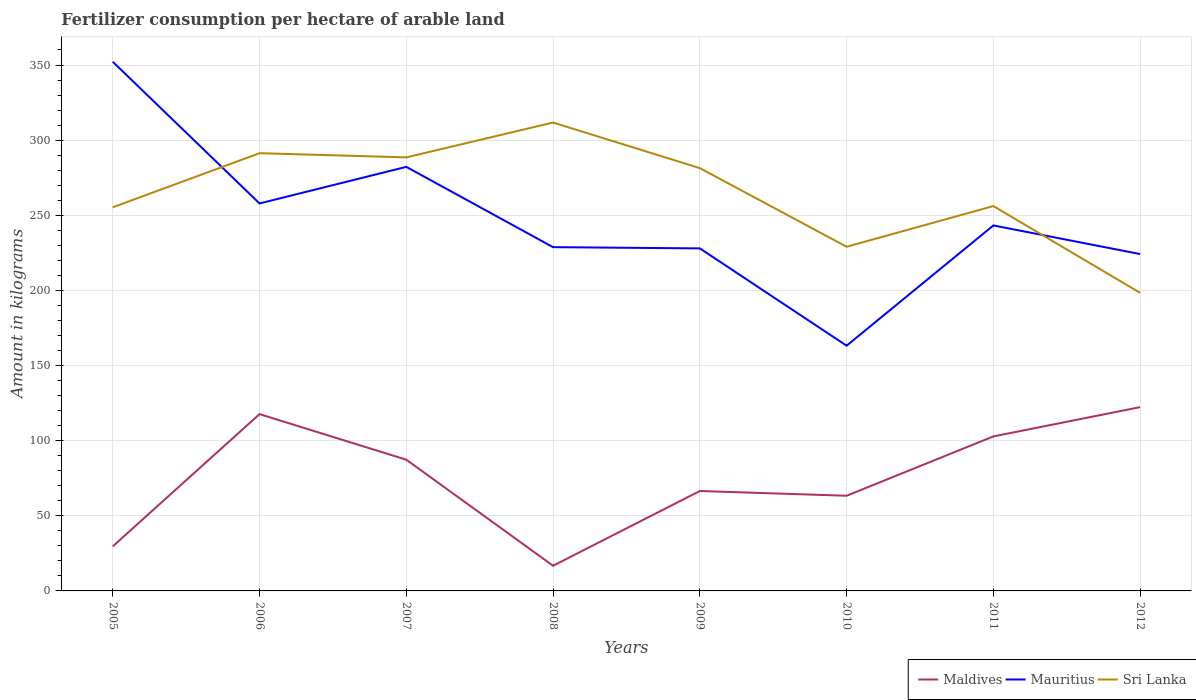How many different coloured lines are there?
Offer a terse response. 3. Is the number of lines equal to the number of legend labels?
Keep it short and to the point. Yes. Across all years, what is the maximum amount of fertilizer consumption in Maldives?
Provide a short and direct response. 16.75. In which year was the amount of fertilizer consumption in Sri Lanka maximum?
Make the answer very short. 2012. What is the total amount of fertilizer consumption in Sri Lanka in the graph?
Give a very brief answer. 92.95. What is the difference between the highest and the second highest amount of fertilizer consumption in Maldives?
Offer a terse response. 105.56. What is the difference between the highest and the lowest amount of fertilizer consumption in Sri Lanka?
Offer a very short reply. 4. What is the difference between two consecutive major ticks on the Y-axis?
Keep it short and to the point. 50. Are the values on the major ticks of Y-axis written in scientific E-notation?
Your response must be concise. No. Does the graph contain grids?
Your response must be concise. Yes. Where does the legend appear in the graph?
Make the answer very short. Bottom right. What is the title of the graph?
Ensure brevity in your answer.  Fertilizer consumption per hectare of arable land. Does "Sierra Leone" appear as one of the legend labels in the graph?
Offer a terse response. No. What is the label or title of the Y-axis?
Make the answer very short. Amount in kilograms. What is the Amount in kilograms in Maldives in 2005?
Offer a very short reply. 29.67. What is the Amount in kilograms in Mauritius in 2005?
Your answer should be very brief. 352.15. What is the Amount in kilograms in Sri Lanka in 2005?
Give a very brief answer. 255.29. What is the Amount in kilograms in Maldives in 2006?
Offer a very short reply. 117.67. What is the Amount in kilograms of Mauritius in 2006?
Make the answer very short. 257.87. What is the Amount in kilograms of Sri Lanka in 2006?
Offer a terse response. 291.32. What is the Amount in kilograms of Maldives in 2007?
Make the answer very short. 87.33. What is the Amount in kilograms in Mauritius in 2007?
Your response must be concise. 282.22. What is the Amount in kilograms in Sri Lanka in 2007?
Give a very brief answer. 288.52. What is the Amount in kilograms of Maldives in 2008?
Offer a terse response. 16.75. What is the Amount in kilograms in Mauritius in 2008?
Provide a short and direct response. 228.78. What is the Amount in kilograms of Sri Lanka in 2008?
Ensure brevity in your answer.  311.71. What is the Amount in kilograms in Maldives in 2009?
Your response must be concise. 66.5. What is the Amount in kilograms in Mauritius in 2009?
Your answer should be compact. 227.96. What is the Amount in kilograms in Sri Lanka in 2009?
Give a very brief answer. 281.38. What is the Amount in kilograms in Maldives in 2010?
Give a very brief answer. 63.33. What is the Amount in kilograms of Mauritius in 2010?
Your answer should be very brief. 163.2. What is the Amount in kilograms of Sri Lanka in 2010?
Offer a terse response. 229.05. What is the Amount in kilograms of Maldives in 2011?
Offer a terse response. 102.82. What is the Amount in kilograms of Mauritius in 2011?
Provide a succinct answer. 243.23. What is the Amount in kilograms of Sri Lanka in 2011?
Offer a very short reply. 256.12. What is the Amount in kilograms in Maldives in 2012?
Provide a short and direct response. 122.31. What is the Amount in kilograms in Mauritius in 2012?
Make the answer very short. 224.18. What is the Amount in kilograms in Sri Lanka in 2012?
Ensure brevity in your answer.  198.37. Across all years, what is the maximum Amount in kilograms of Maldives?
Provide a short and direct response. 122.31. Across all years, what is the maximum Amount in kilograms of Mauritius?
Make the answer very short. 352.15. Across all years, what is the maximum Amount in kilograms in Sri Lanka?
Provide a short and direct response. 311.71. Across all years, what is the minimum Amount in kilograms of Maldives?
Offer a very short reply. 16.75. Across all years, what is the minimum Amount in kilograms in Mauritius?
Give a very brief answer. 163.2. Across all years, what is the minimum Amount in kilograms of Sri Lanka?
Your answer should be compact. 198.37. What is the total Amount in kilograms of Maldives in the graph?
Make the answer very short. 606.38. What is the total Amount in kilograms of Mauritius in the graph?
Offer a very short reply. 1979.6. What is the total Amount in kilograms of Sri Lanka in the graph?
Keep it short and to the point. 2111.76. What is the difference between the Amount in kilograms in Maldives in 2005 and that in 2006?
Offer a very short reply. -88. What is the difference between the Amount in kilograms in Mauritius in 2005 and that in 2006?
Offer a terse response. 94.29. What is the difference between the Amount in kilograms of Sri Lanka in 2005 and that in 2006?
Keep it short and to the point. -36.02. What is the difference between the Amount in kilograms in Maldives in 2005 and that in 2007?
Your answer should be compact. -57.67. What is the difference between the Amount in kilograms in Mauritius in 2005 and that in 2007?
Your answer should be very brief. 69.93. What is the difference between the Amount in kilograms in Sri Lanka in 2005 and that in 2007?
Your response must be concise. -33.23. What is the difference between the Amount in kilograms in Maldives in 2005 and that in 2008?
Offer a terse response. 12.92. What is the difference between the Amount in kilograms in Mauritius in 2005 and that in 2008?
Give a very brief answer. 123.38. What is the difference between the Amount in kilograms of Sri Lanka in 2005 and that in 2008?
Your answer should be very brief. -56.42. What is the difference between the Amount in kilograms in Maldives in 2005 and that in 2009?
Ensure brevity in your answer.  -36.83. What is the difference between the Amount in kilograms in Mauritius in 2005 and that in 2009?
Your answer should be compact. 124.19. What is the difference between the Amount in kilograms in Sri Lanka in 2005 and that in 2009?
Keep it short and to the point. -26.08. What is the difference between the Amount in kilograms of Maldives in 2005 and that in 2010?
Your response must be concise. -33.67. What is the difference between the Amount in kilograms in Mauritius in 2005 and that in 2010?
Offer a terse response. 188.95. What is the difference between the Amount in kilograms in Sri Lanka in 2005 and that in 2010?
Provide a succinct answer. 26.24. What is the difference between the Amount in kilograms of Maldives in 2005 and that in 2011?
Your answer should be very brief. -73.15. What is the difference between the Amount in kilograms of Mauritius in 2005 and that in 2011?
Provide a short and direct response. 108.92. What is the difference between the Amount in kilograms of Sri Lanka in 2005 and that in 2011?
Give a very brief answer. -0.83. What is the difference between the Amount in kilograms of Maldives in 2005 and that in 2012?
Provide a succinct answer. -92.64. What is the difference between the Amount in kilograms of Mauritius in 2005 and that in 2012?
Your response must be concise. 127.97. What is the difference between the Amount in kilograms in Sri Lanka in 2005 and that in 2012?
Offer a terse response. 56.92. What is the difference between the Amount in kilograms of Maldives in 2006 and that in 2007?
Offer a terse response. 30.33. What is the difference between the Amount in kilograms of Mauritius in 2006 and that in 2007?
Keep it short and to the point. -24.35. What is the difference between the Amount in kilograms in Sri Lanka in 2006 and that in 2007?
Your response must be concise. 2.79. What is the difference between the Amount in kilograms of Maldives in 2006 and that in 2008?
Provide a succinct answer. 100.92. What is the difference between the Amount in kilograms in Mauritius in 2006 and that in 2008?
Provide a short and direct response. 29.09. What is the difference between the Amount in kilograms in Sri Lanka in 2006 and that in 2008?
Make the answer very short. -20.4. What is the difference between the Amount in kilograms in Maldives in 2006 and that in 2009?
Keep it short and to the point. 51.17. What is the difference between the Amount in kilograms in Mauritius in 2006 and that in 2009?
Ensure brevity in your answer.  29.91. What is the difference between the Amount in kilograms of Sri Lanka in 2006 and that in 2009?
Give a very brief answer. 9.94. What is the difference between the Amount in kilograms in Maldives in 2006 and that in 2010?
Ensure brevity in your answer.  54.33. What is the difference between the Amount in kilograms in Mauritius in 2006 and that in 2010?
Give a very brief answer. 94.67. What is the difference between the Amount in kilograms of Sri Lanka in 2006 and that in 2010?
Your response must be concise. 62.27. What is the difference between the Amount in kilograms in Maldives in 2006 and that in 2011?
Provide a short and direct response. 14.85. What is the difference between the Amount in kilograms of Mauritius in 2006 and that in 2011?
Your response must be concise. 14.64. What is the difference between the Amount in kilograms of Sri Lanka in 2006 and that in 2011?
Provide a short and direct response. 35.19. What is the difference between the Amount in kilograms of Maldives in 2006 and that in 2012?
Give a very brief answer. -4.64. What is the difference between the Amount in kilograms of Mauritius in 2006 and that in 2012?
Keep it short and to the point. 33.68. What is the difference between the Amount in kilograms in Sri Lanka in 2006 and that in 2012?
Offer a terse response. 92.95. What is the difference between the Amount in kilograms in Maldives in 2007 and that in 2008?
Your answer should be compact. 70.58. What is the difference between the Amount in kilograms in Mauritius in 2007 and that in 2008?
Offer a very short reply. 53.45. What is the difference between the Amount in kilograms of Sri Lanka in 2007 and that in 2008?
Offer a terse response. -23.19. What is the difference between the Amount in kilograms of Maldives in 2007 and that in 2009?
Make the answer very short. 20.83. What is the difference between the Amount in kilograms in Mauritius in 2007 and that in 2009?
Provide a succinct answer. 54.26. What is the difference between the Amount in kilograms of Sri Lanka in 2007 and that in 2009?
Keep it short and to the point. 7.15. What is the difference between the Amount in kilograms of Maldives in 2007 and that in 2010?
Provide a short and direct response. 24. What is the difference between the Amount in kilograms of Mauritius in 2007 and that in 2010?
Keep it short and to the point. 119.02. What is the difference between the Amount in kilograms of Sri Lanka in 2007 and that in 2010?
Offer a terse response. 59.48. What is the difference between the Amount in kilograms in Maldives in 2007 and that in 2011?
Your answer should be compact. -15.49. What is the difference between the Amount in kilograms in Mauritius in 2007 and that in 2011?
Keep it short and to the point. 38.99. What is the difference between the Amount in kilograms in Sri Lanka in 2007 and that in 2011?
Offer a very short reply. 32.4. What is the difference between the Amount in kilograms in Maldives in 2007 and that in 2012?
Your answer should be very brief. -34.97. What is the difference between the Amount in kilograms in Mauritius in 2007 and that in 2012?
Offer a very short reply. 58.04. What is the difference between the Amount in kilograms in Sri Lanka in 2007 and that in 2012?
Provide a short and direct response. 90.16. What is the difference between the Amount in kilograms of Maldives in 2008 and that in 2009?
Provide a succinct answer. -49.75. What is the difference between the Amount in kilograms in Mauritius in 2008 and that in 2009?
Ensure brevity in your answer.  0.81. What is the difference between the Amount in kilograms of Sri Lanka in 2008 and that in 2009?
Ensure brevity in your answer.  30.34. What is the difference between the Amount in kilograms of Maldives in 2008 and that in 2010?
Offer a terse response. -46.58. What is the difference between the Amount in kilograms in Mauritius in 2008 and that in 2010?
Keep it short and to the point. 65.58. What is the difference between the Amount in kilograms in Sri Lanka in 2008 and that in 2010?
Provide a short and direct response. 82.66. What is the difference between the Amount in kilograms in Maldives in 2008 and that in 2011?
Keep it short and to the point. -86.07. What is the difference between the Amount in kilograms of Mauritius in 2008 and that in 2011?
Provide a short and direct response. -14.46. What is the difference between the Amount in kilograms in Sri Lanka in 2008 and that in 2011?
Make the answer very short. 55.59. What is the difference between the Amount in kilograms of Maldives in 2008 and that in 2012?
Your answer should be very brief. -105.56. What is the difference between the Amount in kilograms of Mauritius in 2008 and that in 2012?
Your answer should be very brief. 4.59. What is the difference between the Amount in kilograms in Sri Lanka in 2008 and that in 2012?
Offer a terse response. 113.34. What is the difference between the Amount in kilograms in Maldives in 2009 and that in 2010?
Keep it short and to the point. 3.17. What is the difference between the Amount in kilograms in Mauritius in 2009 and that in 2010?
Give a very brief answer. 64.76. What is the difference between the Amount in kilograms in Sri Lanka in 2009 and that in 2010?
Your response must be concise. 52.33. What is the difference between the Amount in kilograms of Maldives in 2009 and that in 2011?
Make the answer very short. -36.32. What is the difference between the Amount in kilograms in Mauritius in 2009 and that in 2011?
Your response must be concise. -15.27. What is the difference between the Amount in kilograms in Sri Lanka in 2009 and that in 2011?
Your answer should be compact. 25.25. What is the difference between the Amount in kilograms of Maldives in 2009 and that in 2012?
Offer a very short reply. -55.81. What is the difference between the Amount in kilograms in Mauritius in 2009 and that in 2012?
Your answer should be very brief. 3.78. What is the difference between the Amount in kilograms in Sri Lanka in 2009 and that in 2012?
Ensure brevity in your answer.  83.01. What is the difference between the Amount in kilograms in Maldives in 2010 and that in 2011?
Ensure brevity in your answer.  -39.49. What is the difference between the Amount in kilograms in Mauritius in 2010 and that in 2011?
Provide a short and direct response. -80.03. What is the difference between the Amount in kilograms in Sri Lanka in 2010 and that in 2011?
Make the answer very short. -27.08. What is the difference between the Amount in kilograms of Maldives in 2010 and that in 2012?
Offer a very short reply. -58.97. What is the difference between the Amount in kilograms of Mauritius in 2010 and that in 2012?
Ensure brevity in your answer.  -60.98. What is the difference between the Amount in kilograms in Sri Lanka in 2010 and that in 2012?
Keep it short and to the point. 30.68. What is the difference between the Amount in kilograms of Maldives in 2011 and that in 2012?
Your answer should be very brief. -19.49. What is the difference between the Amount in kilograms in Mauritius in 2011 and that in 2012?
Keep it short and to the point. 19.05. What is the difference between the Amount in kilograms of Sri Lanka in 2011 and that in 2012?
Your answer should be very brief. 57.75. What is the difference between the Amount in kilograms of Maldives in 2005 and the Amount in kilograms of Mauritius in 2006?
Make the answer very short. -228.2. What is the difference between the Amount in kilograms of Maldives in 2005 and the Amount in kilograms of Sri Lanka in 2006?
Ensure brevity in your answer.  -261.65. What is the difference between the Amount in kilograms of Mauritius in 2005 and the Amount in kilograms of Sri Lanka in 2006?
Your answer should be very brief. 60.84. What is the difference between the Amount in kilograms in Maldives in 2005 and the Amount in kilograms in Mauritius in 2007?
Offer a very short reply. -252.56. What is the difference between the Amount in kilograms of Maldives in 2005 and the Amount in kilograms of Sri Lanka in 2007?
Make the answer very short. -258.86. What is the difference between the Amount in kilograms of Mauritius in 2005 and the Amount in kilograms of Sri Lanka in 2007?
Provide a short and direct response. 63.63. What is the difference between the Amount in kilograms in Maldives in 2005 and the Amount in kilograms in Mauritius in 2008?
Provide a succinct answer. -199.11. What is the difference between the Amount in kilograms of Maldives in 2005 and the Amount in kilograms of Sri Lanka in 2008?
Ensure brevity in your answer.  -282.05. What is the difference between the Amount in kilograms of Mauritius in 2005 and the Amount in kilograms of Sri Lanka in 2008?
Offer a very short reply. 40.44. What is the difference between the Amount in kilograms in Maldives in 2005 and the Amount in kilograms in Mauritius in 2009?
Keep it short and to the point. -198.3. What is the difference between the Amount in kilograms in Maldives in 2005 and the Amount in kilograms in Sri Lanka in 2009?
Your response must be concise. -251.71. What is the difference between the Amount in kilograms of Mauritius in 2005 and the Amount in kilograms of Sri Lanka in 2009?
Offer a very short reply. 70.78. What is the difference between the Amount in kilograms in Maldives in 2005 and the Amount in kilograms in Mauritius in 2010?
Provide a succinct answer. -133.53. What is the difference between the Amount in kilograms in Maldives in 2005 and the Amount in kilograms in Sri Lanka in 2010?
Keep it short and to the point. -199.38. What is the difference between the Amount in kilograms in Mauritius in 2005 and the Amount in kilograms in Sri Lanka in 2010?
Your response must be concise. 123.11. What is the difference between the Amount in kilograms in Maldives in 2005 and the Amount in kilograms in Mauritius in 2011?
Ensure brevity in your answer.  -213.56. What is the difference between the Amount in kilograms of Maldives in 2005 and the Amount in kilograms of Sri Lanka in 2011?
Provide a succinct answer. -226.46. What is the difference between the Amount in kilograms of Mauritius in 2005 and the Amount in kilograms of Sri Lanka in 2011?
Your answer should be very brief. 96.03. What is the difference between the Amount in kilograms of Maldives in 2005 and the Amount in kilograms of Mauritius in 2012?
Keep it short and to the point. -194.52. What is the difference between the Amount in kilograms in Maldives in 2005 and the Amount in kilograms in Sri Lanka in 2012?
Make the answer very short. -168.7. What is the difference between the Amount in kilograms of Mauritius in 2005 and the Amount in kilograms of Sri Lanka in 2012?
Make the answer very short. 153.78. What is the difference between the Amount in kilograms of Maldives in 2006 and the Amount in kilograms of Mauritius in 2007?
Offer a terse response. -164.56. What is the difference between the Amount in kilograms of Maldives in 2006 and the Amount in kilograms of Sri Lanka in 2007?
Give a very brief answer. -170.86. What is the difference between the Amount in kilograms of Mauritius in 2006 and the Amount in kilograms of Sri Lanka in 2007?
Offer a very short reply. -30.66. What is the difference between the Amount in kilograms of Maldives in 2006 and the Amount in kilograms of Mauritius in 2008?
Offer a terse response. -111.11. What is the difference between the Amount in kilograms in Maldives in 2006 and the Amount in kilograms in Sri Lanka in 2008?
Your answer should be compact. -194.04. What is the difference between the Amount in kilograms of Mauritius in 2006 and the Amount in kilograms of Sri Lanka in 2008?
Your answer should be compact. -53.84. What is the difference between the Amount in kilograms of Maldives in 2006 and the Amount in kilograms of Mauritius in 2009?
Offer a very short reply. -110.3. What is the difference between the Amount in kilograms in Maldives in 2006 and the Amount in kilograms in Sri Lanka in 2009?
Make the answer very short. -163.71. What is the difference between the Amount in kilograms in Mauritius in 2006 and the Amount in kilograms in Sri Lanka in 2009?
Offer a terse response. -23.51. What is the difference between the Amount in kilograms of Maldives in 2006 and the Amount in kilograms of Mauritius in 2010?
Keep it short and to the point. -45.53. What is the difference between the Amount in kilograms of Maldives in 2006 and the Amount in kilograms of Sri Lanka in 2010?
Your answer should be very brief. -111.38. What is the difference between the Amount in kilograms in Mauritius in 2006 and the Amount in kilograms in Sri Lanka in 2010?
Your answer should be compact. 28.82. What is the difference between the Amount in kilograms of Maldives in 2006 and the Amount in kilograms of Mauritius in 2011?
Provide a short and direct response. -125.56. What is the difference between the Amount in kilograms in Maldives in 2006 and the Amount in kilograms in Sri Lanka in 2011?
Your answer should be compact. -138.46. What is the difference between the Amount in kilograms in Mauritius in 2006 and the Amount in kilograms in Sri Lanka in 2011?
Your answer should be compact. 1.74. What is the difference between the Amount in kilograms of Maldives in 2006 and the Amount in kilograms of Mauritius in 2012?
Provide a short and direct response. -106.52. What is the difference between the Amount in kilograms of Maldives in 2006 and the Amount in kilograms of Sri Lanka in 2012?
Provide a succinct answer. -80.7. What is the difference between the Amount in kilograms of Mauritius in 2006 and the Amount in kilograms of Sri Lanka in 2012?
Ensure brevity in your answer.  59.5. What is the difference between the Amount in kilograms of Maldives in 2007 and the Amount in kilograms of Mauritius in 2008?
Your response must be concise. -141.44. What is the difference between the Amount in kilograms in Maldives in 2007 and the Amount in kilograms in Sri Lanka in 2008?
Give a very brief answer. -224.38. What is the difference between the Amount in kilograms in Mauritius in 2007 and the Amount in kilograms in Sri Lanka in 2008?
Give a very brief answer. -29.49. What is the difference between the Amount in kilograms in Maldives in 2007 and the Amount in kilograms in Mauritius in 2009?
Your answer should be compact. -140.63. What is the difference between the Amount in kilograms in Maldives in 2007 and the Amount in kilograms in Sri Lanka in 2009?
Provide a short and direct response. -194.04. What is the difference between the Amount in kilograms in Mauritius in 2007 and the Amount in kilograms in Sri Lanka in 2009?
Ensure brevity in your answer.  0.85. What is the difference between the Amount in kilograms in Maldives in 2007 and the Amount in kilograms in Mauritius in 2010?
Offer a very short reply. -75.87. What is the difference between the Amount in kilograms in Maldives in 2007 and the Amount in kilograms in Sri Lanka in 2010?
Give a very brief answer. -141.71. What is the difference between the Amount in kilograms in Mauritius in 2007 and the Amount in kilograms in Sri Lanka in 2010?
Your response must be concise. 53.17. What is the difference between the Amount in kilograms in Maldives in 2007 and the Amount in kilograms in Mauritius in 2011?
Your answer should be very brief. -155.9. What is the difference between the Amount in kilograms in Maldives in 2007 and the Amount in kilograms in Sri Lanka in 2011?
Your answer should be compact. -168.79. What is the difference between the Amount in kilograms in Mauritius in 2007 and the Amount in kilograms in Sri Lanka in 2011?
Offer a very short reply. 26.1. What is the difference between the Amount in kilograms of Maldives in 2007 and the Amount in kilograms of Mauritius in 2012?
Offer a very short reply. -136.85. What is the difference between the Amount in kilograms in Maldives in 2007 and the Amount in kilograms in Sri Lanka in 2012?
Give a very brief answer. -111.04. What is the difference between the Amount in kilograms of Mauritius in 2007 and the Amount in kilograms of Sri Lanka in 2012?
Your answer should be very brief. 83.85. What is the difference between the Amount in kilograms in Maldives in 2008 and the Amount in kilograms in Mauritius in 2009?
Ensure brevity in your answer.  -211.21. What is the difference between the Amount in kilograms of Maldives in 2008 and the Amount in kilograms of Sri Lanka in 2009?
Offer a terse response. -264.63. What is the difference between the Amount in kilograms of Mauritius in 2008 and the Amount in kilograms of Sri Lanka in 2009?
Make the answer very short. -52.6. What is the difference between the Amount in kilograms in Maldives in 2008 and the Amount in kilograms in Mauritius in 2010?
Ensure brevity in your answer.  -146.45. What is the difference between the Amount in kilograms in Maldives in 2008 and the Amount in kilograms in Sri Lanka in 2010?
Provide a succinct answer. -212.3. What is the difference between the Amount in kilograms of Mauritius in 2008 and the Amount in kilograms of Sri Lanka in 2010?
Make the answer very short. -0.27. What is the difference between the Amount in kilograms of Maldives in 2008 and the Amount in kilograms of Mauritius in 2011?
Offer a very short reply. -226.48. What is the difference between the Amount in kilograms in Maldives in 2008 and the Amount in kilograms in Sri Lanka in 2011?
Offer a terse response. -239.37. What is the difference between the Amount in kilograms in Mauritius in 2008 and the Amount in kilograms in Sri Lanka in 2011?
Your answer should be very brief. -27.35. What is the difference between the Amount in kilograms in Maldives in 2008 and the Amount in kilograms in Mauritius in 2012?
Your answer should be compact. -207.43. What is the difference between the Amount in kilograms in Maldives in 2008 and the Amount in kilograms in Sri Lanka in 2012?
Ensure brevity in your answer.  -181.62. What is the difference between the Amount in kilograms in Mauritius in 2008 and the Amount in kilograms in Sri Lanka in 2012?
Your answer should be very brief. 30.41. What is the difference between the Amount in kilograms in Maldives in 2009 and the Amount in kilograms in Mauritius in 2010?
Give a very brief answer. -96.7. What is the difference between the Amount in kilograms of Maldives in 2009 and the Amount in kilograms of Sri Lanka in 2010?
Your answer should be compact. -162.55. What is the difference between the Amount in kilograms in Mauritius in 2009 and the Amount in kilograms in Sri Lanka in 2010?
Your response must be concise. -1.08. What is the difference between the Amount in kilograms in Maldives in 2009 and the Amount in kilograms in Mauritius in 2011?
Offer a terse response. -176.73. What is the difference between the Amount in kilograms in Maldives in 2009 and the Amount in kilograms in Sri Lanka in 2011?
Provide a succinct answer. -189.62. What is the difference between the Amount in kilograms of Mauritius in 2009 and the Amount in kilograms of Sri Lanka in 2011?
Provide a succinct answer. -28.16. What is the difference between the Amount in kilograms of Maldives in 2009 and the Amount in kilograms of Mauritius in 2012?
Give a very brief answer. -157.68. What is the difference between the Amount in kilograms of Maldives in 2009 and the Amount in kilograms of Sri Lanka in 2012?
Offer a terse response. -131.87. What is the difference between the Amount in kilograms in Mauritius in 2009 and the Amount in kilograms in Sri Lanka in 2012?
Ensure brevity in your answer.  29.59. What is the difference between the Amount in kilograms of Maldives in 2010 and the Amount in kilograms of Mauritius in 2011?
Offer a very short reply. -179.9. What is the difference between the Amount in kilograms in Maldives in 2010 and the Amount in kilograms in Sri Lanka in 2011?
Provide a succinct answer. -192.79. What is the difference between the Amount in kilograms in Mauritius in 2010 and the Amount in kilograms in Sri Lanka in 2011?
Give a very brief answer. -92.92. What is the difference between the Amount in kilograms in Maldives in 2010 and the Amount in kilograms in Mauritius in 2012?
Ensure brevity in your answer.  -160.85. What is the difference between the Amount in kilograms of Maldives in 2010 and the Amount in kilograms of Sri Lanka in 2012?
Make the answer very short. -135.04. What is the difference between the Amount in kilograms of Mauritius in 2010 and the Amount in kilograms of Sri Lanka in 2012?
Offer a very short reply. -35.17. What is the difference between the Amount in kilograms in Maldives in 2011 and the Amount in kilograms in Mauritius in 2012?
Ensure brevity in your answer.  -121.36. What is the difference between the Amount in kilograms in Maldives in 2011 and the Amount in kilograms in Sri Lanka in 2012?
Keep it short and to the point. -95.55. What is the difference between the Amount in kilograms in Mauritius in 2011 and the Amount in kilograms in Sri Lanka in 2012?
Your answer should be compact. 44.86. What is the average Amount in kilograms of Maldives per year?
Provide a succinct answer. 75.8. What is the average Amount in kilograms in Mauritius per year?
Your answer should be compact. 247.45. What is the average Amount in kilograms of Sri Lanka per year?
Your response must be concise. 263.97. In the year 2005, what is the difference between the Amount in kilograms of Maldives and Amount in kilograms of Mauritius?
Your response must be concise. -322.49. In the year 2005, what is the difference between the Amount in kilograms of Maldives and Amount in kilograms of Sri Lanka?
Keep it short and to the point. -225.63. In the year 2005, what is the difference between the Amount in kilograms in Mauritius and Amount in kilograms in Sri Lanka?
Provide a short and direct response. 96.86. In the year 2006, what is the difference between the Amount in kilograms in Maldives and Amount in kilograms in Mauritius?
Offer a very short reply. -140.2. In the year 2006, what is the difference between the Amount in kilograms in Maldives and Amount in kilograms in Sri Lanka?
Give a very brief answer. -173.65. In the year 2006, what is the difference between the Amount in kilograms of Mauritius and Amount in kilograms of Sri Lanka?
Provide a short and direct response. -33.45. In the year 2007, what is the difference between the Amount in kilograms of Maldives and Amount in kilograms of Mauritius?
Your answer should be very brief. -194.89. In the year 2007, what is the difference between the Amount in kilograms of Maldives and Amount in kilograms of Sri Lanka?
Ensure brevity in your answer.  -201.19. In the year 2007, what is the difference between the Amount in kilograms of Mauritius and Amount in kilograms of Sri Lanka?
Provide a short and direct response. -6.3. In the year 2008, what is the difference between the Amount in kilograms of Maldives and Amount in kilograms of Mauritius?
Offer a terse response. -212.03. In the year 2008, what is the difference between the Amount in kilograms in Maldives and Amount in kilograms in Sri Lanka?
Make the answer very short. -294.96. In the year 2008, what is the difference between the Amount in kilograms of Mauritius and Amount in kilograms of Sri Lanka?
Make the answer very short. -82.94. In the year 2009, what is the difference between the Amount in kilograms in Maldives and Amount in kilograms in Mauritius?
Offer a terse response. -161.46. In the year 2009, what is the difference between the Amount in kilograms in Maldives and Amount in kilograms in Sri Lanka?
Your answer should be compact. -214.88. In the year 2009, what is the difference between the Amount in kilograms in Mauritius and Amount in kilograms in Sri Lanka?
Ensure brevity in your answer.  -53.41. In the year 2010, what is the difference between the Amount in kilograms of Maldives and Amount in kilograms of Mauritius?
Provide a short and direct response. -99.87. In the year 2010, what is the difference between the Amount in kilograms in Maldives and Amount in kilograms in Sri Lanka?
Ensure brevity in your answer.  -165.71. In the year 2010, what is the difference between the Amount in kilograms of Mauritius and Amount in kilograms of Sri Lanka?
Make the answer very short. -65.85. In the year 2011, what is the difference between the Amount in kilograms of Maldives and Amount in kilograms of Mauritius?
Your answer should be compact. -140.41. In the year 2011, what is the difference between the Amount in kilograms in Maldives and Amount in kilograms in Sri Lanka?
Your answer should be compact. -153.3. In the year 2011, what is the difference between the Amount in kilograms of Mauritius and Amount in kilograms of Sri Lanka?
Provide a short and direct response. -12.89. In the year 2012, what is the difference between the Amount in kilograms in Maldives and Amount in kilograms in Mauritius?
Make the answer very short. -101.88. In the year 2012, what is the difference between the Amount in kilograms of Maldives and Amount in kilograms of Sri Lanka?
Make the answer very short. -76.06. In the year 2012, what is the difference between the Amount in kilograms of Mauritius and Amount in kilograms of Sri Lanka?
Ensure brevity in your answer.  25.81. What is the ratio of the Amount in kilograms in Maldives in 2005 to that in 2006?
Keep it short and to the point. 0.25. What is the ratio of the Amount in kilograms of Mauritius in 2005 to that in 2006?
Offer a terse response. 1.37. What is the ratio of the Amount in kilograms of Sri Lanka in 2005 to that in 2006?
Ensure brevity in your answer.  0.88. What is the ratio of the Amount in kilograms in Maldives in 2005 to that in 2007?
Keep it short and to the point. 0.34. What is the ratio of the Amount in kilograms in Mauritius in 2005 to that in 2007?
Give a very brief answer. 1.25. What is the ratio of the Amount in kilograms in Sri Lanka in 2005 to that in 2007?
Provide a short and direct response. 0.88. What is the ratio of the Amount in kilograms of Maldives in 2005 to that in 2008?
Offer a very short reply. 1.77. What is the ratio of the Amount in kilograms in Mauritius in 2005 to that in 2008?
Your response must be concise. 1.54. What is the ratio of the Amount in kilograms in Sri Lanka in 2005 to that in 2008?
Make the answer very short. 0.82. What is the ratio of the Amount in kilograms in Maldives in 2005 to that in 2009?
Ensure brevity in your answer.  0.45. What is the ratio of the Amount in kilograms of Mauritius in 2005 to that in 2009?
Ensure brevity in your answer.  1.54. What is the ratio of the Amount in kilograms of Sri Lanka in 2005 to that in 2009?
Offer a terse response. 0.91. What is the ratio of the Amount in kilograms of Maldives in 2005 to that in 2010?
Provide a short and direct response. 0.47. What is the ratio of the Amount in kilograms in Mauritius in 2005 to that in 2010?
Provide a succinct answer. 2.16. What is the ratio of the Amount in kilograms of Sri Lanka in 2005 to that in 2010?
Your response must be concise. 1.11. What is the ratio of the Amount in kilograms in Maldives in 2005 to that in 2011?
Ensure brevity in your answer.  0.29. What is the ratio of the Amount in kilograms of Mauritius in 2005 to that in 2011?
Your response must be concise. 1.45. What is the ratio of the Amount in kilograms of Maldives in 2005 to that in 2012?
Offer a very short reply. 0.24. What is the ratio of the Amount in kilograms in Mauritius in 2005 to that in 2012?
Keep it short and to the point. 1.57. What is the ratio of the Amount in kilograms in Sri Lanka in 2005 to that in 2012?
Your answer should be compact. 1.29. What is the ratio of the Amount in kilograms in Maldives in 2006 to that in 2007?
Your answer should be compact. 1.35. What is the ratio of the Amount in kilograms in Mauritius in 2006 to that in 2007?
Your answer should be compact. 0.91. What is the ratio of the Amount in kilograms of Sri Lanka in 2006 to that in 2007?
Your response must be concise. 1.01. What is the ratio of the Amount in kilograms in Maldives in 2006 to that in 2008?
Make the answer very short. 7.02. What is the ratio of the Amount in kilograms of Mauritius in 2006 to that in 2008?
Your response must be concise. 1.13. What is the ratio of the Amount in kilograms of Sri Lanka in 2006 to that in 2008?
Ensure brevity in your answer.  0.93. What is the ratio of the Amount in kilograms of Maldives in 2006 to that in 2009?
Make the answer very short. 1.77. What is the ratio of the Amount in kilograms of Mauritius in 2006 to that in 2009?
Offer a very short reply. 1.13. What is the ratio of the Amount in kilograms in Sri Lanka in 2006 to that in 2009?
Ensure brevity in your answer.  1.04. What is the ratio of the Amount in kilograms in Maldives in 2006 to that in 2010?
Offer a very short reply. 1.86. What is the ratio of the Amount in kilograms of Mauritius in 2006 to that in 2010?
Keep it short and to the point. 1.58. What is the ratio of the Amount in kilograms of Sri Lanka in 2006 to that in 2010?
Your answer should be compact. 1.27. What is the ratio of the Amount in kilograms in Maldives in 2006 to that in 2011?
Provide a succinct answer. 1.14. What is the ratio of the Amount in kilograms in Mauritius in 2006 to that in 2011?
Your answer should be compact. 1.06. What is the ratio of the Amount in kilograms in Sri Lanka in 2006 to that in 2011?
Your answer should be compact. 1.14. What is the ratio of the Amount in kilograms of Maldives in 2006 to that in 2012?
Your response must be concise. 0.96. What is the ratio of the Amount in kilograms of Mauritius in 2006 to that in 2012?
Provide a succinct answer. 1.15. What is the ratio of the Amount in kilograms of Sri Lanka in 2006 to that in 2012?
Your answer should be very brief. 1.47. What is the ratio of the Amount in kilograms of Maldives in 2007 to that in 2008?
Offer a terse response. 5.21. What is the ratio of the Amount in kilograms of Mauritius in 2007 to that in 2008?
Your answer should be compact. 1.23. What is the ratio of the Amount in kilograms in Sri Lanka in 2007 to that in 2008?
Ensure brevity in your answer.  0.93. What is the ratio of the Amount in kilograms in Maldives in 2007 to that in 2009?
Offer a terse response. 1.31. What is the ratio of the Amount in kilograms in Mauritius in 2007 to that in 2009?
Your answer should be compact. 1.24. What is the ratio of the Amount in kilograms in Sri Lanka in 2007 to that in 2009?
Your answer should be compact. 1.03. What is the ratio of the Amount in kilograms of Maldives in 2007 to that in 2010?
Offer a terse response. 1.38. What is the ratio of the Amount in kilograms in Mauritius in 2007 to that in 2010?
Provide a short and direct response. 1.73. What is the ratio of the Amount in kilograms in Sri Lanka in 2007 to that in 2010?
Your answer should be very brief. 1.26. What is the ratio of the Amount in kilograms of Maldives in 2007 to that in 2011?
Make the answer very short. 0.85. What is the ratio of the Amount in kilograms in Mauritius in 2007 to that in 2011?
Keep it short and to the point. 1.16. What is the ratio of the Amount in kilograms of Sri Lanka in 2007 to that in 2011?
Provide a short and direct response. 1.13. What is the ratio of the Amount in kilograms in Maldives in 2007 to that in 2012?
Offer a very short reply. 0.71. What is the ratio of the Amount in kilograms in Mauritius in 2007 to that in 2012?
Keep it short and to the point. 1.26. What is the ratio of the Amount in kilograms in Sri Lanka in 2007 to that in 2012?
Your response must be concise. 1.45. What is the ratio of the Amount in kilograms in Maldives in 2008 to that in 2009?
Your answer should be compact. 0.25. What is the ratio of the Amount in kilograms in Sri Lanka in 2008 to that in 2009?
Offer a very short reply. 1.11. What is the ratio of the Amount in kilograms in Maldives in 2008 to that in 2010?
Ensure brevity in your answer.  0.26. What is the ratio of the Amount in kilograms in Mauritius in 2008 to that in 2010?
Your response must be concise. 1.4. What is the ratio of the Amount in kilograms of Sri Lanka in 2008 to that in 2010?
Give a very brief answer. 1.36. What is the ratio of the Amount in kilograms in Maldives in 2008 to that in 2011?
Your answer should be very brief. 0.16. What is the ratio of the Amount in kilograms in Mauritius in 2008 to that in 2011?
Keep it short and to the point. 0.94. What is the ratio of the Amount in kilograms of Sri Lanka in 2008 to that in 2011?
Offer a very short reply. 1.22. What is the ratio of the Amount in kilograms of Maldives in 2008 to that in 2012?
Your response must be concise. 0.14. What is the ratio of the Amount in kilograms of Mauritius in 2008 to that in 2012?
Keep it short and to the point. 1.02. What is the ratio of the Amount in kilograms of Sri Lanka in 2008 to that in 2012?
Ensure brevity in your answer.  1.57. What is the ratio of the Amount in kilograms in Mauritius in 2009 to that in 2010?
Provide a succinct answer. 1.4. What is the ratio of the Amount in kilograms of Sri Lanka in 2009 to that in 2010?
Ensure brevity in your answer.  1.23. What is the ratio of the Amount in kilograms of Maldives in 2009 to that in 2011?
Your answer should be compact. 0.65. What is the ratio of the Amount in kilograms of Mauritius in 2009 to that in 2011?
Offer a very short reply. 0.94. What is the ratio of the Amount in kilograms of Sri Lanka in 2009 to that in 2011?
Your response must be concise. 1.1. What is the ratio of the Amount in kilograms of Maldives in 2009 to that in 2012?
Ensure brevity in your answer.  0.54. What is the ratio of the Amount in kilograms in Mauritius in 2009 to that in 2012?
Keep it short and to the point. 1.02. What is the ratio of the Amount in kilograms in Sri Lanka in 2009 to that in 2012?
Offer a terse response. 1.42. What is the ratio of the Amount in kilograms in Maldives in 2010 to that in 2011?
Your answer should be compact. 0.62. What is the ratio of the Amount in kilograms of Mauritius in 2010 to that in 2011?
Make the answer very short. 0.67. What is the ratio of the Amount in kilograms in Sri Lanka in 2010 to that in 2011?
Provide a short and direct response. 0.89. What is the ratio of the Amount in kilograms of Maldives in 2010 to that in 2012?
Ensure brevity in your answer.  0.52. What is the ratio of the Amount in kilograms in Mauritius in 2010 to that in 2012?
Your answer should be compact. 0.73. What is the ratio of the Amount in kilograms of Sri Lanka in 2010 to that in 2012?
Give a very brief answer. 1.15. What is the ratio of the Amount in kilograms in Maldives in 2011 to that in 2012?
Your answer should be compact. 0.84. What is the ratio of the Amount in kilograms of Mauritius in 2011 to that in 2012?
Provide a succinct answer. 1.08. What is the ratio of the Amount in kilograms of Sri Lanka in 2011 to that in 2012?
Your answer should be very brief. 1.29. What is the difference between the highest and the second highest Amount in kilograms in Maldives?
Offer a very short reply. 4.64. What is the difference between the highest and the second highest Amount in kilograms in Mauritius?
Give a very brief answer. 69.93. What is the difference between the highest and the second highest Amount in kilograms of Sri Lanka?
Offer a terse response. 20.4. What is the difference between the highest and the lowest Amount in kilograms of Maldives?
Ensure brevity in your answer.  105.56. What is the difference between the highest and the lowest Amount in kilograms of Mauritius?
Keep it short and to the point. 188.95. What is the difference between the highest and the lowest Amount in kilograms of Sri Lanka?
Ensure brevity in your answer.  113.34. 